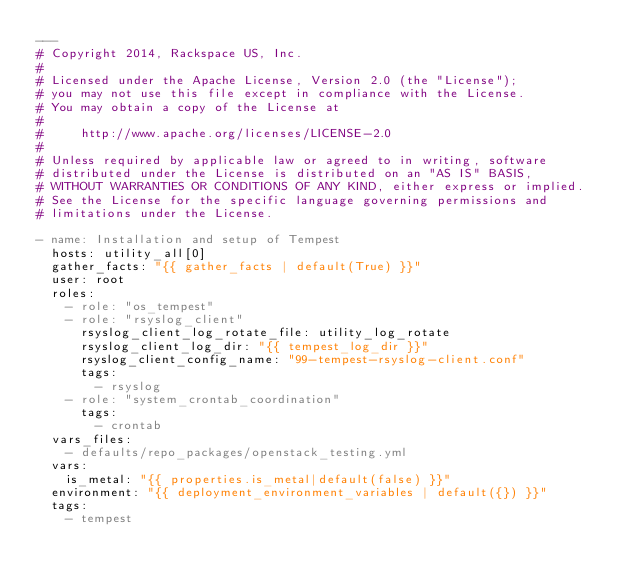<code> <loc_0><loc_0><loc_500><loc_500><_YAML_>---
# Copyright 2014, Rackspace US, Inc.
#
# Licensed under the Apache License, Version 2.0 (the "License");
# you may not use this file except in compliance with the License.
# You may obtain a copy of the License at
#
#     http://www.apache.org/licenses/LICENSE-2.0
#
# Unless required by applicable law or agreed to in writing, software
# distributed under the License is distributed on an "AS IS" BASIS,
# WITHOUT WARRANTIES OR CONDITIONS OF ANY KIND, either express or implied.
# See the License for the specific language governing permissions and
# limitations under the License.

- name: Installation and setup of Tempest
  hosts: utility_all[0]
  gather_facts: "{{ gather_facts | default(True) }}"
  user: root
  roles:
    - role: "os_tempest"
    - role: "rsyslog_client"
      rsyslog_client_log_rotate_file: utility_log_rotate
      rsyslog_client_log_dir: "{{ tempest_log_dir }}"
      rsyslog_client_config_name: "99-tempest-rsyslog-client.conf"
      tags:
        - rsyslog
    - role: "system_crontab_coordination"
      tags:
        - crontab
  vars_files:
    - defaults/repo_packages/openstack_testing.yml
  vars:
    is_metal: "{{ properties.is_metal|default(false) }}"
  environment: "{{ deployment_environment_variables | default({}) }}"
  tags:
    - tempest
</code> 